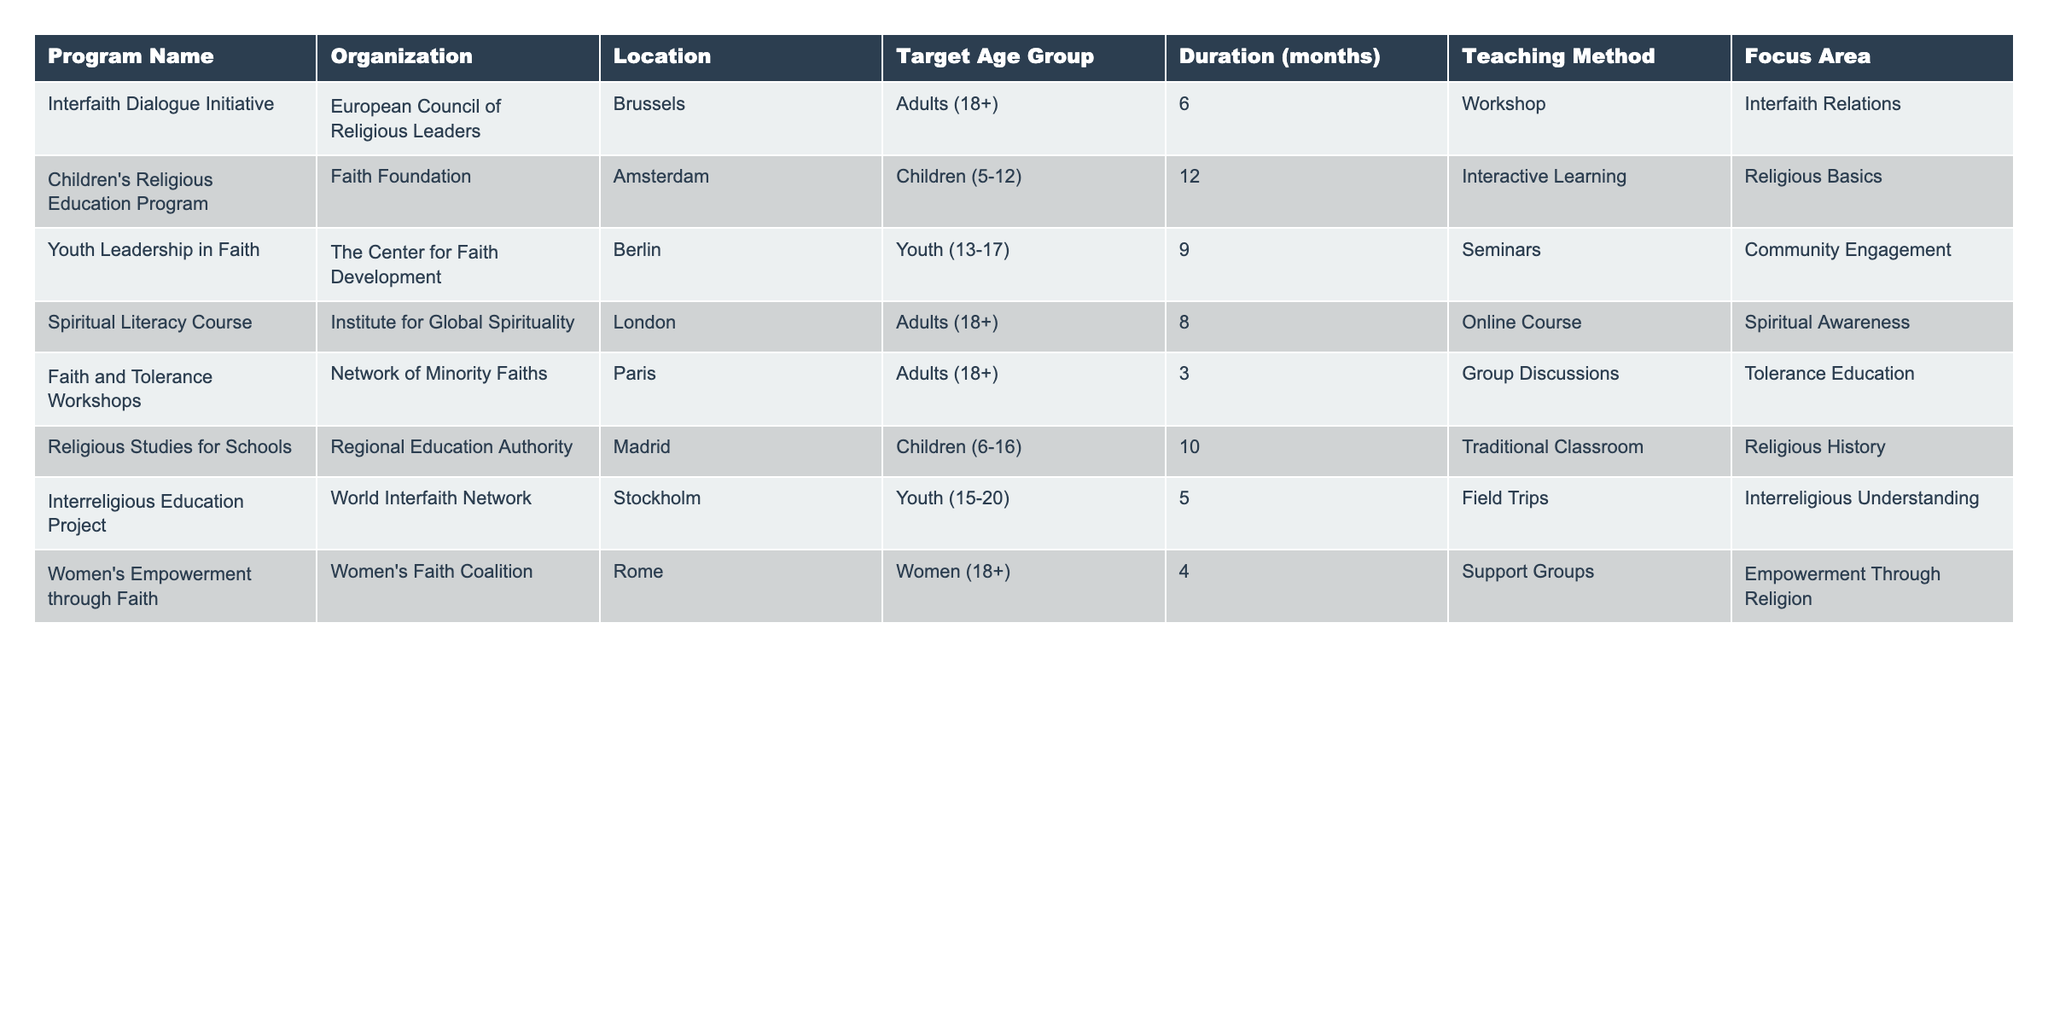What is the duration of the "Youth Leadership in Faith" program? The table shows that the "Youth Leadership in Faith" program has a duration of 9 months.
Answer: 9 months Which organization offers the "Women's Empowerment through Faith" program? According to the table, the "Women's Empowerment through Faith" program is offered by the Women's Faith Coalition.
Answer: Women's Faith Coalition How many programs are targeted at adults? There are 4 programs listed in the table that target adults: "Interfaith Dialogue Initiative", "Spiritual Literacy Course", "Faith and Tolerance Workshops", and "Women's Empowerment through Faith".
Answer: 4 programs What is the primary focus area of the "Children's Religious Education Program"? The table indicates that the focus area of the "Children's Religious Education Program" is "Religious Basics".
Answer: Religious Basics Is there a program that focuses on interfaith relations and has a duration of more than 5 months? The "Interfaith Dialogue Initiative" focuses on interfaith relations and has a duration of 6 months, which meets both criteria. Therefore, the answer is yes.
Answer: Yes What is the average duration of the programs targeted at children? The programs targeted at children are the "Children's Religious Education Program" (12 months) and "Religious Studies for Schools" (10 months). The total duration is 12 + 10 = 22 months, and there are 2 programs, so the average is 22 / 2 = 11 months.
Answer: 11 months Which teaching method is employed in the "Interreligious Education Project"? The table shows that the "Interreligious Education Project" employs the teaching method of field trips.
Answer: Field trips Are all programs targeting youth between the ages of 13 and 17? No, the "Interreligious Education Project" targets youth aged 15 to 20, which includes those older than 17. Hence, not all programs target exclusively ages 13 to 17.
Answer: No Which program has the shortest duration and what is it? The "Faith and Tolerance Workshops" has the shortest duration of 3 months, according to the data in the table.
Answer: 3 months How many programs use seminars as their teaching method? The table lists the "Youth Leadership in Faith" program as using seminars. Therefore, there is only 1 program that uses this method.
Answer: 1 program What is the focus area of the program with the longest duration? The "Children's Religious Education Program" has the longest duration of 12 months, and its focus area is "Religious Basics".
Answer: Religious Basics 